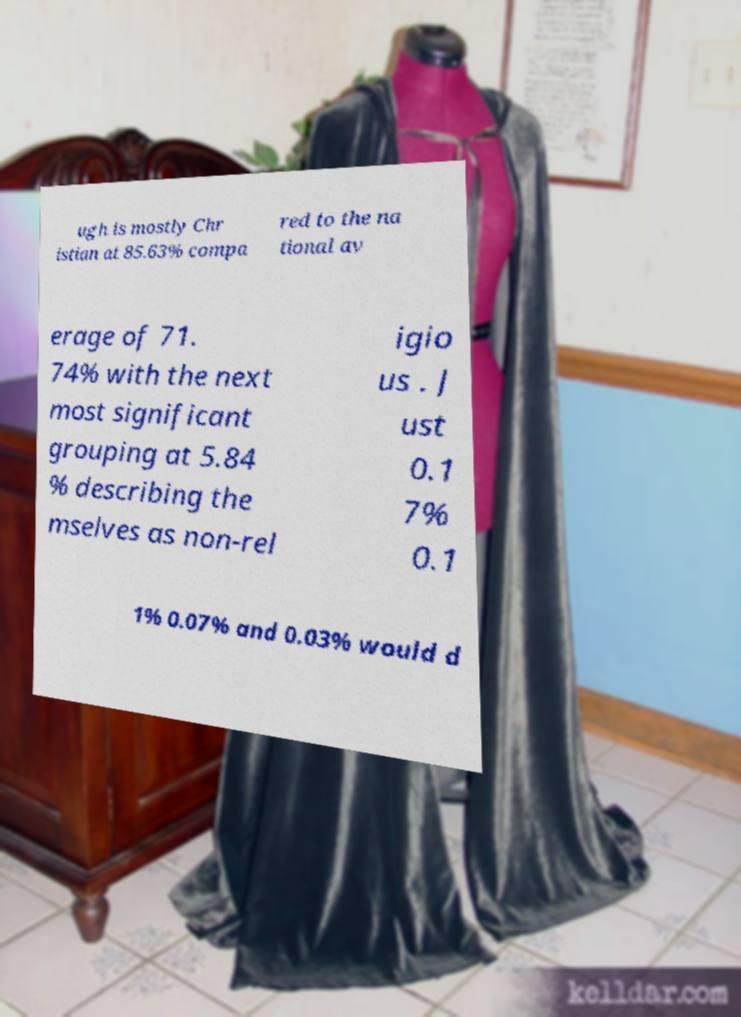Can you accurately transcribe the text from the provided image for me? ugh is mostly Chr istian at 85.63% compa red to the na tional av erage of 71. 74% with the next most significant grouping at 5.84 % describing the mselves as non-rel igio us . J ust 0.1 7% 0.1 1% 0.07% and 0.03% would d 